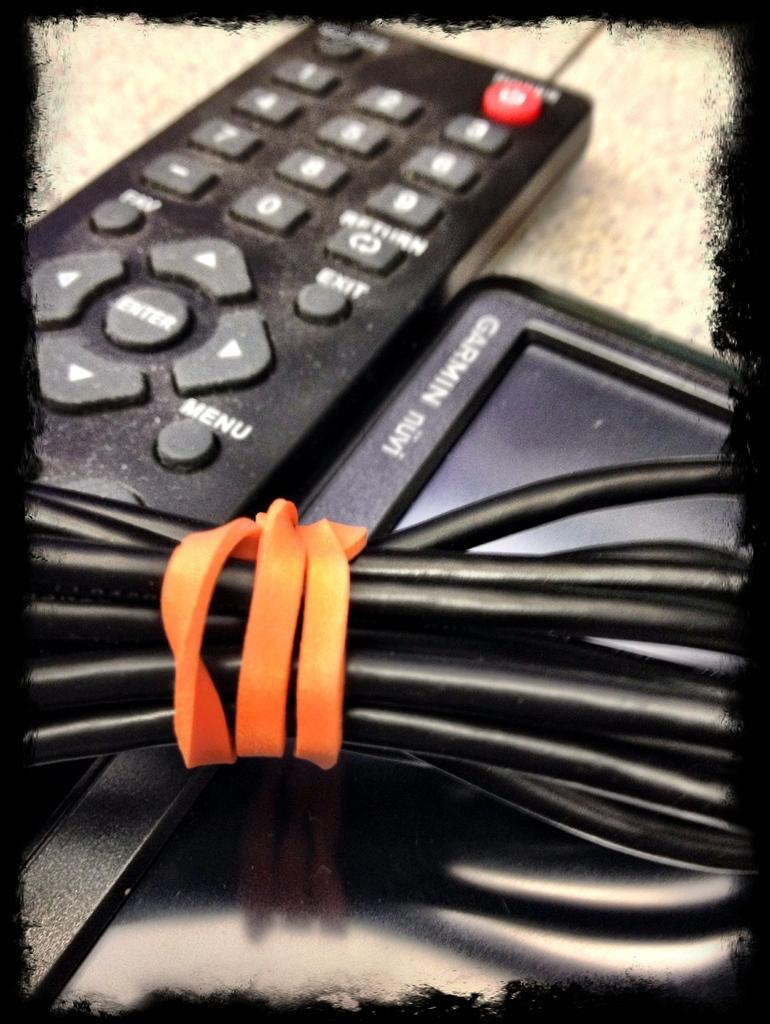<image>
Provide a brief description of the given image. A Garmin GPS unit with a cord on top of it. 